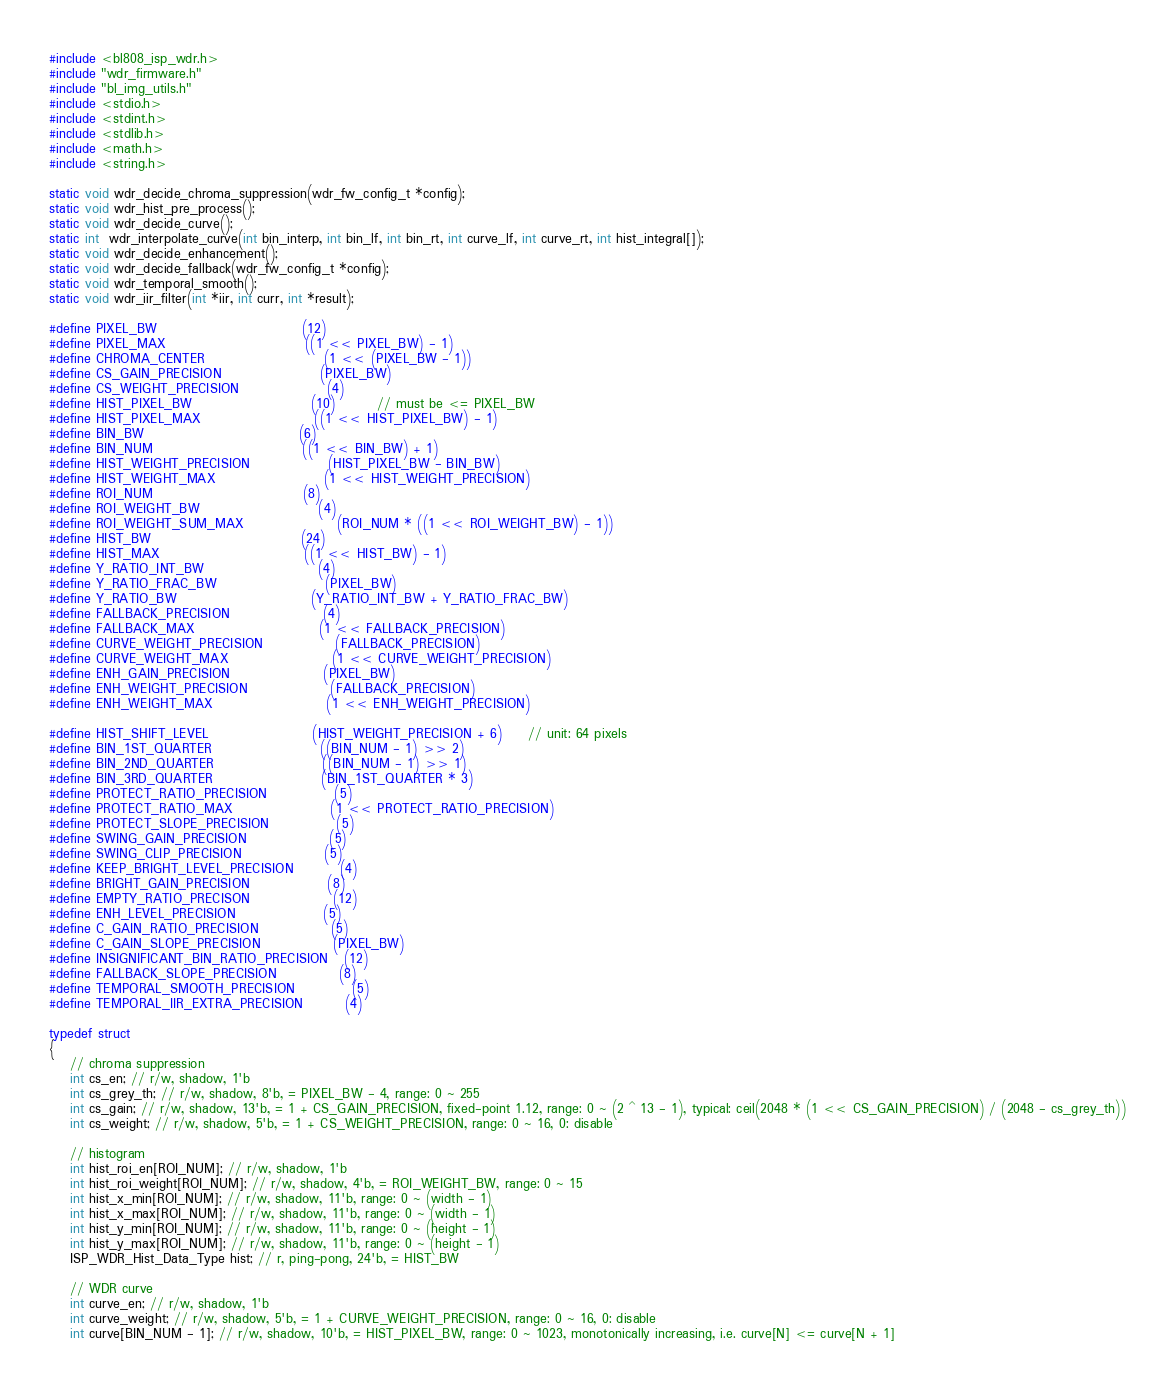<code> <loc_0><loc_0><loc_500><loc_500><_C_>#include <bl808_isp_wdr.h>
#include "wdr_firmware.h"
#include "bl_img_utils.h"
#include <stdio.h>
#include <stdint.h>
#include <stdlib.h>
#include <math.h>
#include <string.h>

static void wdr_decide_chroma_suppression(wdr_fw_config_t *config);
static void wdr_hist_pre_process();
static void wdr_decide_curve();
static int  wdr_interpolate_curve(int bin_interp, int bin_lf, int bin_rt, int curve_lf, int curve_rt, int hist_integral[]);
static void wdr_decide_enhancement();
static void wdr_decide_fallback(wdr_fw_config_t *config);
static void wdr_temporal_smooth();
static void wdr_iir_filter(int *iir, int curr, int *result);

#define PIXEL_BW                            (12)
#define PIXEL_MAX                           ((1 << PIXEL_BW) - 1)
#define CHROMA_CENTER                       (1 << (PIXEL_BW - 1))
#define CS_GAIN_PRECISION                   (PIXEL_BW)
#define CS_WEIGHT_PRECISION                 (4)
#define HIST_PIXEL_BW                       (10)        // must be <= PIXEL_BW
#define HIST_PIXEL_MAX                      ((1 << HIST_PIXEL_BW) - 1)
#define BIN_BW                              (6)
#define BIN_NUM                             ((1 << BIN_BW) + 1)
#define HIST_WEIGHT_PRECISION               (HIST_PIXEL_BW - BIN_BW)
#define HIST_WEIGHT_MAX                     (1 << HIST_WEIGHT_PRECISION)
#define ROI_NUM                             (8)
#define ROI_WEIGHT_BW                       (4)
#define ROI_WEIGHT_SUM_MAX                  (ROI_NUM * ((1 << ROI_WEIGHT_BW) - 1))
#define HIST_BW                             (24)
#define HIST_MAX                            ((1 << HIST_BW) - 1)
#define Y_RATIO_INT_BW                      (4)
#define Y_RATIO_FRAC_BW                     (PIXEL_BW)
#define Y_RATIO_BW                          (Y_RATIO_INT_BW + Y_RATIO_FRAC_BW)
#define FALLBACK_PRECISION                  (4)
#define FALLBACK_MAX                        (1 << FALLBACK_PRECISION)
#define CURVE_WEIGHT_PRECISION              (FALLBACK_PRECISION)
#define CURVE_WEIGHT_MAX                    (1 << CURVE_WEIGHT_PRECISION)
#define ENH_GAIN_PRECISION                  (PIXEL_BW)
#define ENH_WEIGHT_PRECISION                (FALLBACK_PRECISION)
#define ENH_WEIGHT_MAX                      (1 << ENH_WEIGHT_PRECISION)

#define HIST_SHIFT_LEVEL                    (HIST_WEIGHT_PRECISION + 6)     // unit: 64 pixels
#define BIN_1ST_QUARTER                     ((BIN_NUM - 1) >> 2)
#define BIN_2ND_QUARTER                     ((BIN_NUM - 1) >> 1)
#define BIN_3RD_QUARTER                     (BIN_1ST_QUARTER * 3)
#define PROTECT_RATIO_PRECISION             (5)
#define PROTECT_RATIO_MAX                   (1 << PROTECT_RATIO_PRECISION)
#define PROTECT_SLOPE_PRECISION             (5)
#define SWING_GAIN_PRECISION                (5)
#define SWING_CLIP_PRECISION                (5)
#define KEEP_BRIGHT_LEVEL_PRECISION         (4)
#define BRIGHT_GAIN_PRECISION               (8)
#define EMPTY_RATIO_PRECISON                (12)
#define ENH_LEVEL_PRECISION                 (5)
#define C_GAIN_RATIO_PRECISION              (5)
#define C_GAIN_SLOPE_PRECISION              (PIXEL_BW)
#define INSIGNIFICANT_BIN_RATIO_PRECISION   (12)
#define FALLBACK_SLOPE_PRECISION            (8)
#define TEMPORAL_SMOOTH_PRECISION           (5)
#define TEMPORAL_IIR_EXTRA_PRECISION        (4)

typedef struct
{
    // chroma suppression
    int cs_en; // r/w, shadow, 1'b
    int cs_grey_th; // r/w, shadow, 8'b, = PIXEL_BW - 4, range: 0 ~ 255
    int cs_gain; // r/w, shadow, 13'b, = 1 + CS_GAIN_PRECISION, fixed-point 1.12, range: 0 ~ (2 ^ 13 - 1), typical: ceil(2048 * (1 << CS_GAIN_PRECISION) / (2048 - cs_grey_th))
    int cs_weight; // r/w, shadow, 5'b, = 1 + CS_WEIGHT_PRECISION, range: 0 ~ 16, 0: disable

    // histogram
    int hist_roi_en[ROI_NUM]; // r/w, shadow, 1'b
    int hist_roi_weight[ROI_NUM]; // r/w, shadow, 4'b, = ROI_WEIGHT_BW, range: 0 ~ 15
    int hist_x_min[ROI_NUM]; // r/w, shadow, 11'b, range: 0 ~ (width - 1)
    int hist_x_max[ROI_NUM]; // r/w, shadow, 11'b, range: 0 ~ (width - 1)
    int hist_y_min[ROI_NUM]; // r/w, shadow, 11'b, range: 0 ~ (height - 1)
    int hist_y_max[ROI_NUM]; // r/w, shadow, 11'b, range: 0 ~ (height - 1)
    ISP_WDR_Hist_Data_Type hist; // r, ping-pong, 24'b, = HIST_BW

    // WDR curve
    int curve_en; // r/w, shadow, 1'b
    int curve_weight; // r/w, shadow, 5'b, = 1 + CURVE_WEIGHT_PRECISION, range: 0 ~ 16, 0: disable
    int curve[BIN_NUM - 1]; // r/w, shadow, 10'b, = HIST_PIXEL_BW, range: 0 ~ 1023, monotonically increasing, i.e. curve[N] <= curve[N + 1]
</code> 